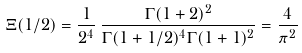Convert formula to latex. <formula><loc_0><loc_0><loc_500><loc_500>\Xi ( 1 / 2 ) = \frac { 1 } { 2 ^ { 4 } } \, \frac { \Gamma ( 1 + 2 ) ^ { 2 } } { \Gamma ( 1 + 1 / 2 ) ^ { 4 } \Gamma ( 1 + 1 ) ^ { 2 } } = \frac { 4 } { \pi ^ { 2 } }</formula> 